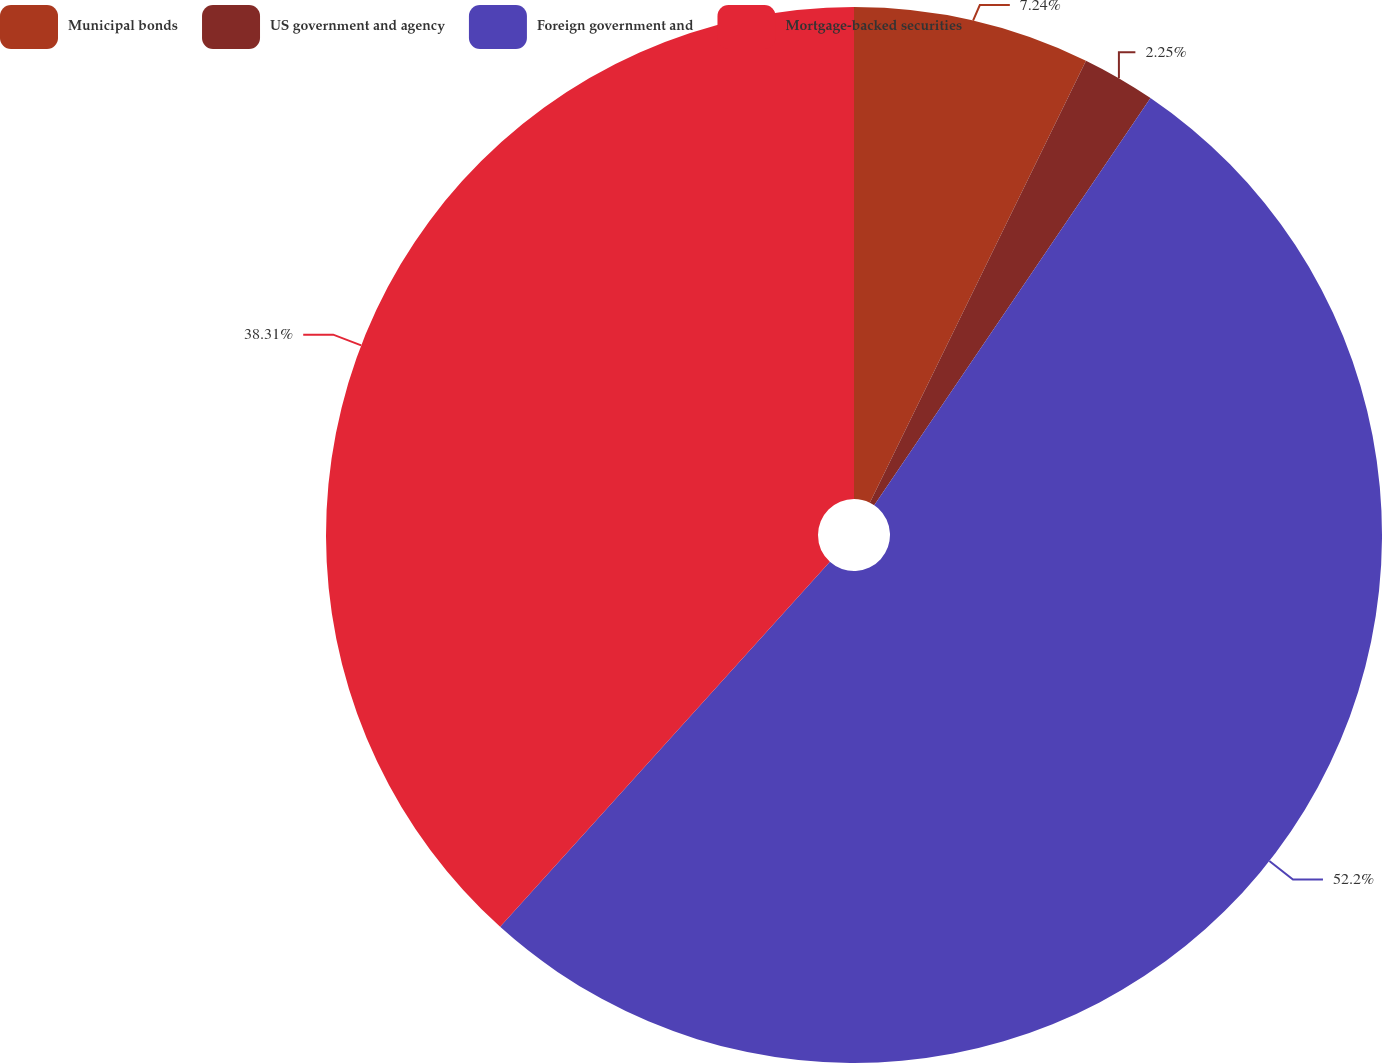Convert chart. <chart><loc_0><loc_0><loc_500><loc_500><pie_chart><fcel>Municipal bonds<fcel>US government and agency<fcel>Foreign government and<fcel>Mortgage-backed securities<nl><fcel>7.24%<fcel>2.25%<fcel>52.2%<fcel>38.31%<nl></chart> 